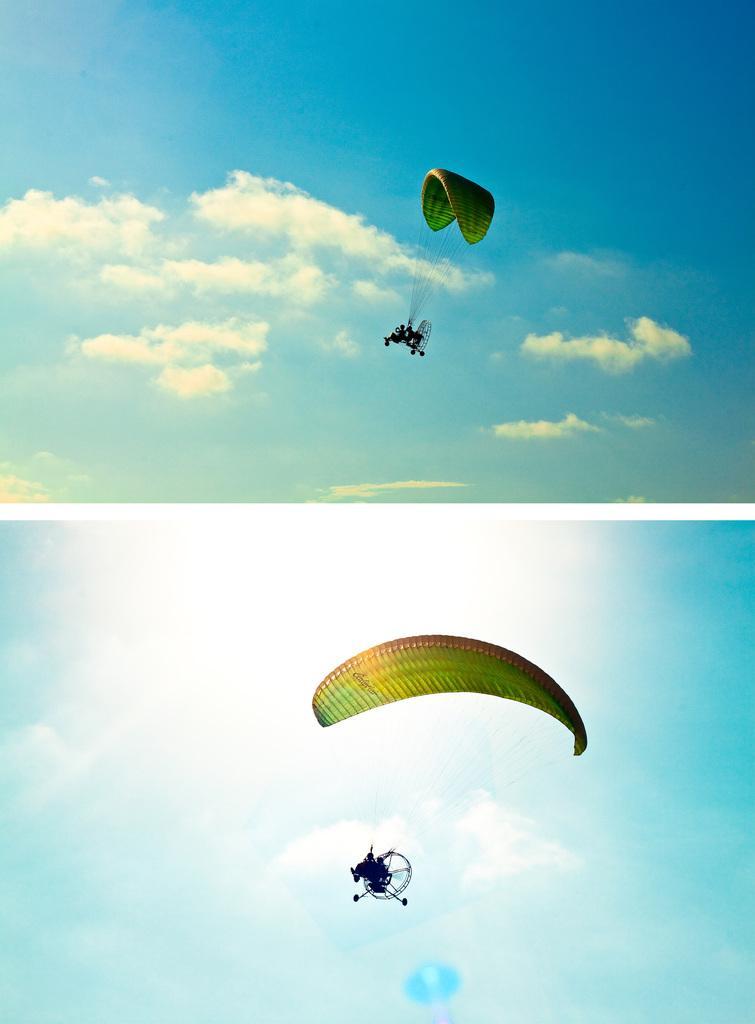In one or two sentences, can you explain what this image depicts? The picture is collage of two pictures. At the bottom we can see a person para riding. At the top we can see people para riding. In the both the images we can see clouds and sky. 